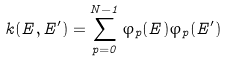<formula> <loc_0><loc_0><loc_500><loc_500>k ( E , E ^ { \prime } ) = \sum _ { p = 0 } ^ { N - 1 } \varphi _ { p } ( E ) \varphi _ { p } ( E ^ { \prime } )</formula> 